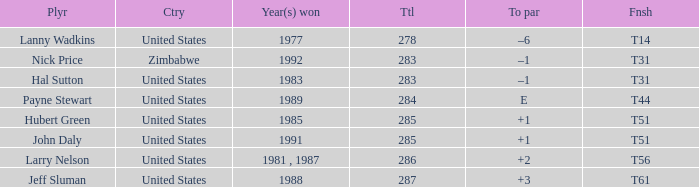What is Year(s) Won, when Finish is "T31", and when Player is "Nick Price"? 1992.0. Help me parse the entirety of this table. {'header': ['Plyr', 'Ctry', 'Year(s) won', 'Ttl', 'To par', 'Fnsh'], 'rows': [['Lanny Wadkins', 'United States', '1977', '278', '–6', 'T14'], ['Nick Price', 'Zimbabwe', '1992', '283', '–1', 'T31'], ['Hal Sutton', 'United States', '1983', '283', '–1', 'T31'], ['Payne Stewart', 'United States', '1989', '284', 'E', 'T44'], ['Hubert Green', 'United States', '1985', '285', '+1', 'T51'], ['John Daly', 'United States', '1991', '285', '+1', 'T51'], ['Larry Nelson', 'United States', '1981 , 1987', '286', '+2', 'T56'], ['Jeff Sluman', 'United States', '1988', '287', '+3', 'T61']]} 